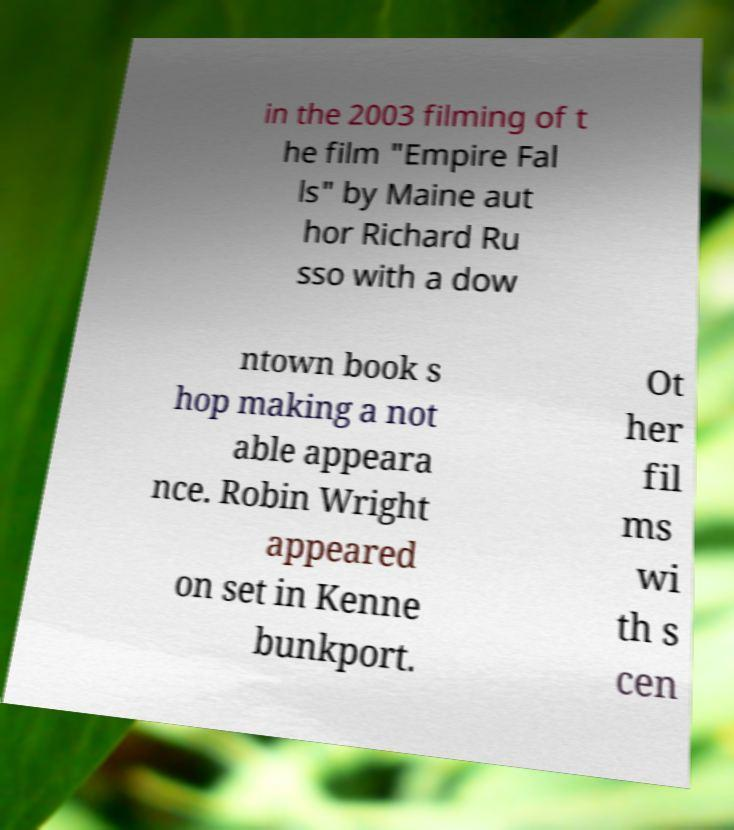Please identify and transcribe the text found in this image. in the 2003 filming of t he film "Empire Fal ls" by Maine aut hor Richard Ru sso with a dow ntown book s hop making a not able appeara nce. Robin Wright appeared on set in Kenne bunkport. Ot her fil ms wi th s cen 